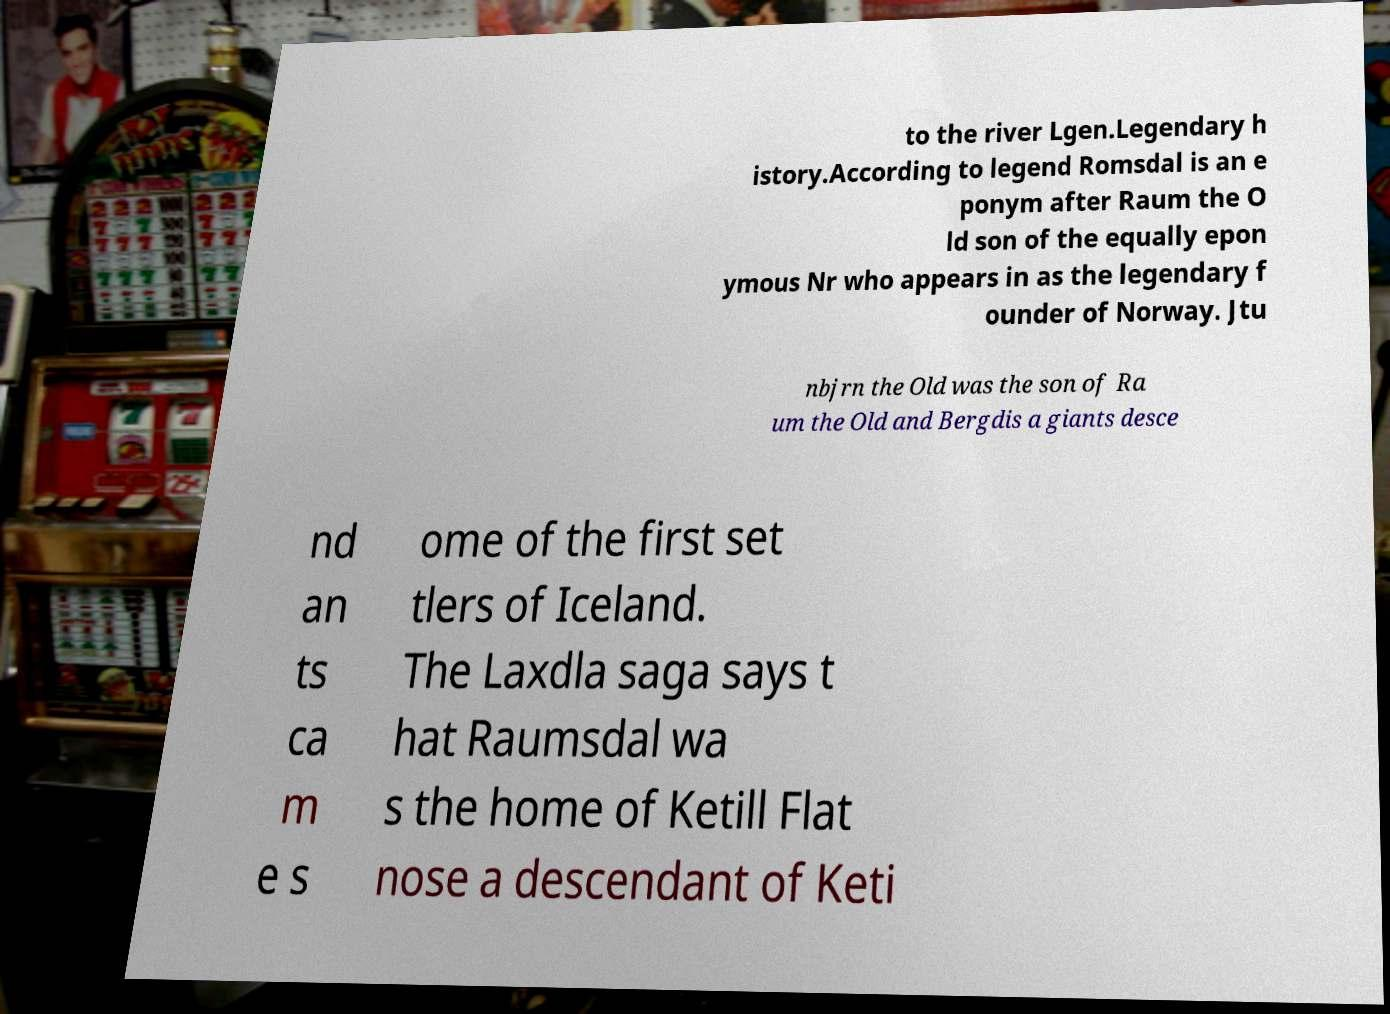Please read and relay the text visible in this image. What does it say? to the river Lgen.Legendary h istory.According to legend Romsdal is an e ponym after Raum the O ld son of the equally epon ymous Nr who appears in as the legendary f ounder of Norway. Jtu nbjrn the Old was the son of Ra um the Old and Bergdis a giants desce nd an ts ca m e s ome of the first set tlers of Iceland. The Laxdla saga says t hat Raumsdal wa s the home of Ketill Flat nose a descendant of Keti 